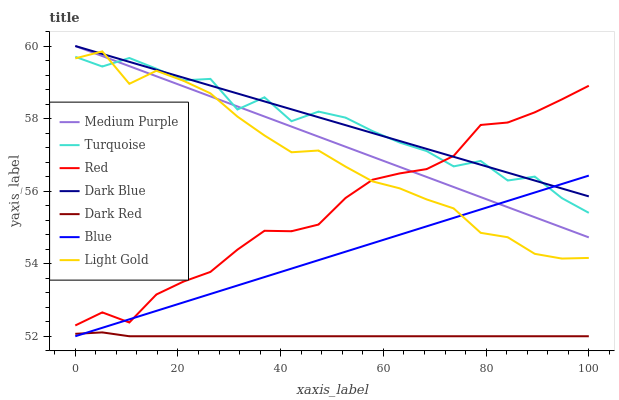Does Turquoise have the minimum area under the curve?
Answer yes or no. No. Does Turquoise have the maximum area under the curve?
Answer yes or no. No. Is Dark Red the smoothest?
Answer yes or no. No. Is Dark Red the roughest?
Answer yes or no. No. Does Turquoise have the lowest value?
Answer yes or no. No. Does Turquoise have the highest value?
Answer yes or no. No. Is Dark Red less than Dark Blue?
Answer yes or no. Yes. Is Light Gold greater than Dark Red?
Answer yes or no. Yes. Does Dark Red intersect Dark Blue?
Answer yes or no. No. 